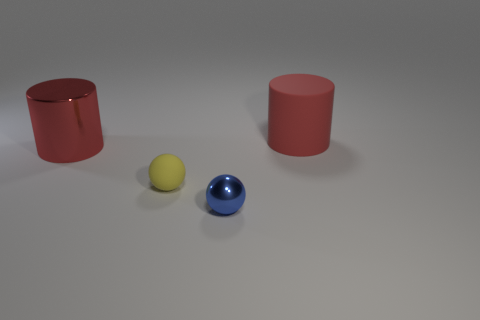Is the number of large red metallic cylinders that are on the left side of the blue metal object less than the number of large red matte cylinders?
Your response must be concise. No. What number of other objects are there of the same shape as the small yellow object?
Provide a succinct answer. 1. Are there any other things that are the same color as the big metal cylinder?
Offer a terse response. Yes. There is a tiny shiny thing; is it the same color as the big cylinder that is on the left side of the large matte cylinder?
Provide a short and direct response. No. What number of other objects are there of the same size as the metallic cylinder?
Your answer should be very brief. 1. What size is the cylinder that is the same color as the large metal thing?
Your answer should be very brief. Large. How many cylinders are big red matte things or small cyan metal things?
Provide a succinct answer. 1. Do the large red thing that is on the right side of the small metal object and the tiny blue shiny object have the same shape?
Make the answer very short. No. Are there more big shiny cylinders that are to the right of the tiny blue metallic ball than tiny rubber balls?
Offer a very short reply. No. There is a rubber ball that is the same size as the blue metal ball; what color is it?
Your response must be concise. Yellow. 